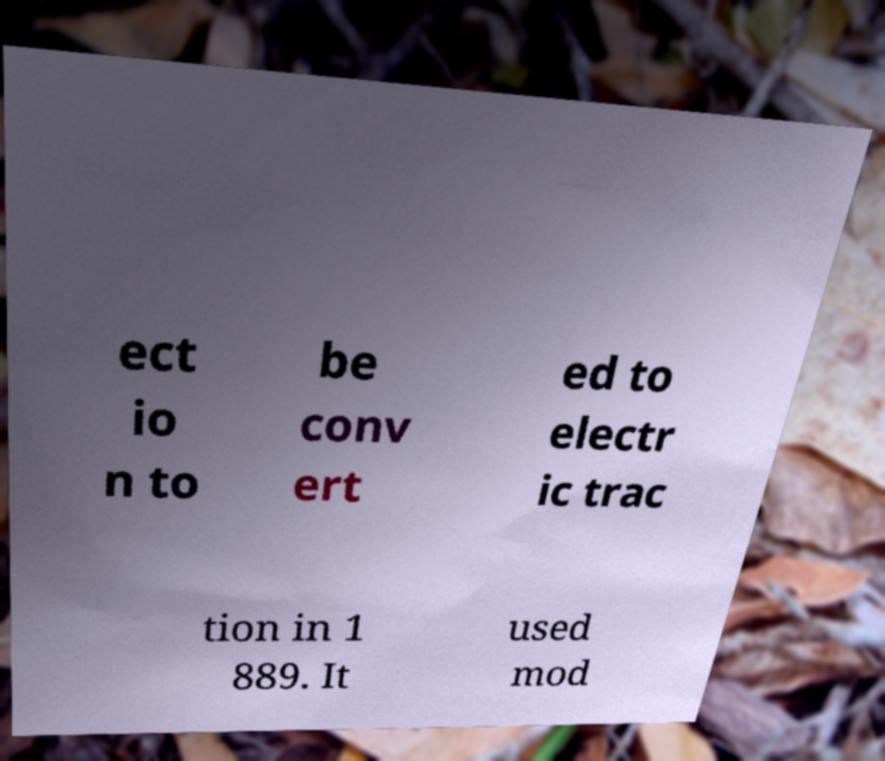For documentation purposes, I need the text within this image transcribed. Could you provide that? ect io n to be conv ert ed to electr ic trac tion in 1 889. It used mod 